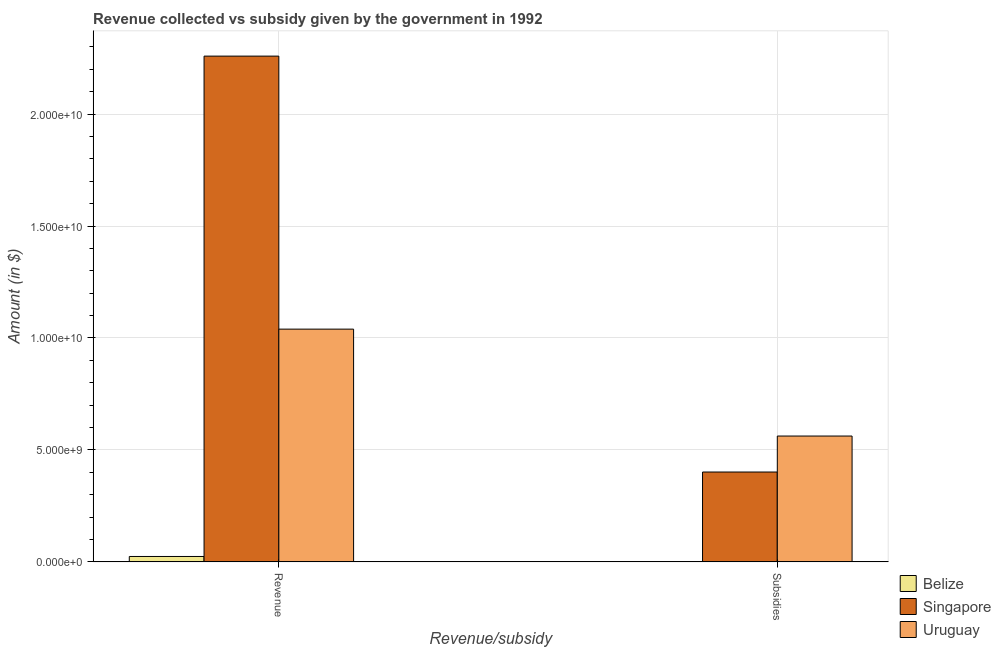How many groups of bars are there?
Provide a succinct answer. 2. Are the number of bars per tick equal to the number of legend labels?
Keep it short and to the point. Yes. Are the number of bars on each tick of the X-axis equal?
Offer a very short reply. Yes. How many bars are there on the 1st tick from the left?
Offer a very short reply. 3. How many bars are there on the 1st tick from the right?
Your response must be concise. 3. What is the label of the 2nd group of bars from the left?
Offer a very short reply. Subsidies. What is the amount of subsidies given in Belize?
Give a very brief answer. 1.47e+07. Across all countries, what is the maximum amount of revenue collected?
Make the answer very short. 2.26e+1. Across all countries, what is the minimum amount of subsidies given?
Ensure brevity in your answer.  1.47e+07. In which country was the amount of subsidies given maximum?
Provide a short and direct response. Uruguay. In which country was the amount of subsidies given minimum?
Ensure brevity in your answer.  Belize. What is the total amount of subsidies given in the graph?
Your answer should be compact. 9.65e+09. What is the difference between the amount of revenue collected in Belize and that in Singapore?
Keep it short and to the point. -2.23e+1. What is the difference between the amount of subsidies given in Belize and the amount of revenue collected in Uruguay?
Provide a succinct answer. -1.04e+1. What is the average amount of revenue collected per country?
Provide a succinct answer. 1.11e+1. What is the difference between the amount of revenue collected and amount of subsidies given in Uruguay?
Offer a very short reply. 4.78e+09. In how many countries, is the amount of subsidies given greater than 2000000000 $?
Your response must be concise. 2. What is the ratio of the amount of revenue collected in Uruguay to that in Belize?
Your answer should be compact. 42.88. In how many countries, is the amount of subsidies given greater than the average amount of subsidies given taken over all countries?
Ensure brevity in your answer.  2. What does the 2nd bar from the left in Subsidies represents?
Offer a terse response. Singapore. What does the 3rd bar from the right in Revenue represents?
Offer a terse response. Belize. How many bars are there?
Ensure brevity in your answer.  6. How many countries are there in the graph?
Ensure brevity in your answer.  3. What is the difference between two consecutive major ticks on the Y-axis?
Your response must be concise. 5.00e+09. Does the graph contain any zero values?
Ensure brevity in your answer.  No. Does the graph contain grids?
Make the answer very short. Yes. How many legend labels are there?
Offer a very short reply. 3. How are the legend labels stacked?
Provide a short and direct response. Vertical. What is the title of the graph?
Give a very brief answer. Revenue collected vs subsidy given by the government in 1992. What is the label or title of the X-axis?
Keep it short and to the point. Revenue/subsidy. What is the label or title of the Y-axis?
Offer a very short reply. Amount (in $). What is the Amount (in $) in Belize in Revenue?
Ensure brevity in your answer.  2.42e+08. What is the Amount (in $) in Singapore in Revenue?
Your answer should be very brief. 2.26e+1. What is the Amount (in $) in Uruguay in Revenue?
Ensure brevity in your answer.  1.04e+1. What is the Amount (in $) in Belize in Subsidies?
Give a very brief answer. 1.47e+07. What is the Amount (in $) in Singapore in Subsidies?
Your answer should be compact. 4.01e+09. What is the Amount (in $) of Uruguay in Subsidies?
Make the answer very short. 5.62e+09. Across all Revenue/subsidy, what is the maximum Amount (in $) in Belize?
Give a very brief answer. 2.42e+08. Across all Revenue/subsidy, what is the maximum Amount (in $) of Singapore?
Provide a short and direct response. 2.26e+1. Across all Revenue/subsidy, what is the maximum Amount (in $) in Uruguay?
Provide a succinct answer. 1.04e+1. Across all Revenue/subsidy, what is the minimum Amount (in $) of Belize?
Your answer should be very brief. 1.47e+07. Across all Revenue/subsidy, what is the minimum Amount (in $) in Singapore?
Give a very brief answer. 4.01e+09. Across all Revenue/subsidy, what is the minimum Amount (in $) in Uruguay?
Ensure brevity in your answer.  5.62e+09. What is the total Amount (in $) in Belize in the graph?
Offer a very short reply. 2.57e+08. What is the total Amount (in $) of Singapore in the graph?
Ensure brevity in your answer.  2.66e+1. What is the total Amount (in $) of Uruguay in the graph?
Your response must be concise. 1.60e+1. What is the difference between the Amount (in $) in Belize in Revenue and that in Subsidies?
Give a very brief answer. 2.28e+08. What is the difference between the Amount (in $) in Singapore in Revenue and that in Subsidies?
Your answer should be very brief. 1.86e+1. What is the difference between the Amount (in $) in Uruguay in Revenue and that in Subsidies?
Give a very brief answer. 4.78e+09. What is the difference between the Amount (in $) of Belize in Revenue and the Amount (in $) of Singapore in Subsidies?
Offer a very short reply. -3.77e+09. What is the difference between the Amount (in $) in Belize in Revenue and the Amount (in $) in Uruguay in Subsidies?
Your response must be concise. -5.38e+09. What is the difference between the Amount (in $) of Singapore in Revenue and the Amount (in $) of Uruguay in Subsidies?
Keep it short and to the point. 1.70e+1. What is the average Amount (in $) of Belize per Revenue/subsidy?
Your answer should be compact. 1.29e+08. What is the average Amount (in $) of Singapore per Revenue/subsidy?
Provide a succinct answer. 1.33e+1. What is the average Amount (in $) in Uruguay per Revenue/subsidy?
Your response must be concise. 8.01e+09. What is the difference between the Amount (in $) of Belize and Amount (in $) of Singapore in Revenue?
Provide a short and direct response. -2.23e+1. What is the difference between the Amount (in $) in Belize and Amount (in $) in Uruguay in Revenue?
Make the answer very short. -1.02e+1. What is the difference between the Amount (in $) of Singapore and Amount (in $) of Uruguay in Revenue?
Offer a very short reply. 1.22e+1. What is the difference between the Amount (in $) in Belize and Amount (in $) in Singapore in Subsidies?
Offer a terse response. -4.00e+09. What is the difference between the Amount (in $) in Belize and Amount (in $) in Uruguay in Subsidies?
Provide a short and direct response. -5.61e+09. What is the difference between the Amount (in $) in Singapore and Amount (in $) in Uruguay in Subsidies?
Offer a terse response. -1.61e+09. What is the ratio of the Amount (in $) of Belize in Revenue to that in Subsidies?
Keep it short and to the point. 16.53. What is the ratio of the Amount (in $) of Singapore in Revenue to that in Subsidies?
Provide a succinct answer. 5.63. What is the ratio of the Amount (in $) of Uruguay in Revenue to that in Subsidies?
Your answer should be compact. 1.85. What is the difference between the highest and the second highest Amount (in $) of Belize?
Make the answer very short. 2.28e+08. What is the difference between the highest and the second highest Amount (in $) in Singapore?
Make the answer very short. 1.86e+1. What is the difference between the highest and the second highest Amount (in $) of Uruguay?
Keep it short and to the point. 4.78e+09. What is the difference between the highest and the lowest Amount (in $) in Belize?
Provide a short and direct response. 2.28e+08. What is the difference between the highest and the lowest Amount (in $) of Singapore?
Give a very brief answer. 1.86e+1. What is the difference between the highest and the lowest Amount (in $) of Uruguay?
Your answer should be very brief. 4.78e+09. 